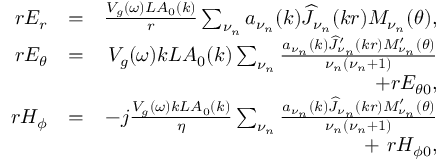Convert formula to latex. <formula><loc_0><loc_0><loc_500><loc_500>\begin{array} { r l r } { r E _ { r } } & { = } & { \frac { V _ { g } ( \omega ) L A _ { 0 } ( k ) } { r } \sum _ { \nu _ { n } } a _ { \nu _ { n } } ( k ) \widehat { J } _ { \nu _ { n } } ( k r ) M _ { \nu _ { n } } ( \theta ) , } \\ { r E _ { \theta } } & { = } & { V _ { g } ( \omega ) k L A _ { 0 } ( k ) \sum _ { \nu _ { n } } \frac { a _ { \nu _ { n } } ( k ) \widehat { J } _ { \nu _ { n } } ^ { \prime } ( k r ) M _ { \nu _ { n } } ^ { \prime } ( \theta ) } { \nu _ { n } ( \nu _ { n } + 1 ) } } \\ & { + r E _ { \theta 0 } , } \\ { r H _ { \phi } } & { = } & { - j \frac { V _ { g } ( \omega ) k L A _ { 0 } ( k ) } { \eta } \sum _ { \nu _ { n } } \frac { a _ { \nu _ { n } } ( k ) \widehat { J } _ { \nu _ { n } } ( k r ) M _ { \nu _ { n } } ^ { \prime } ( \theta ) } { \nu _ { n } ( \nu _ { n } + 1 ) } } \\ & { + \ r H _ { \phi 0 } , } \end{array}</formula> 